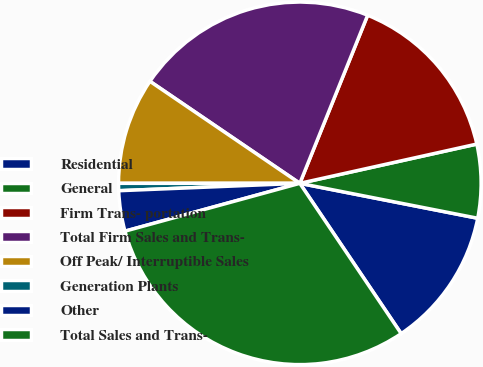<chart> <loc_0><loc_0><loc_500><loc_500><pie_chart><fcel>Residential<fcel>General<fcel>Firm Trans- portation<fcel>Total Firm Sales and Trans-<fcel>Off Peak/ Interruptible Sales<fcel>Generation Plants<fcel>Other<fcel>Total Sales and Trans-<nl><fcel>12.47%<fcel>6.56%<fcel>15.42%<fcel>21.59%<fcel>9.51%<fcel>0.65%<fcel>3.6%<fcel>30.19%<nl></chart> 